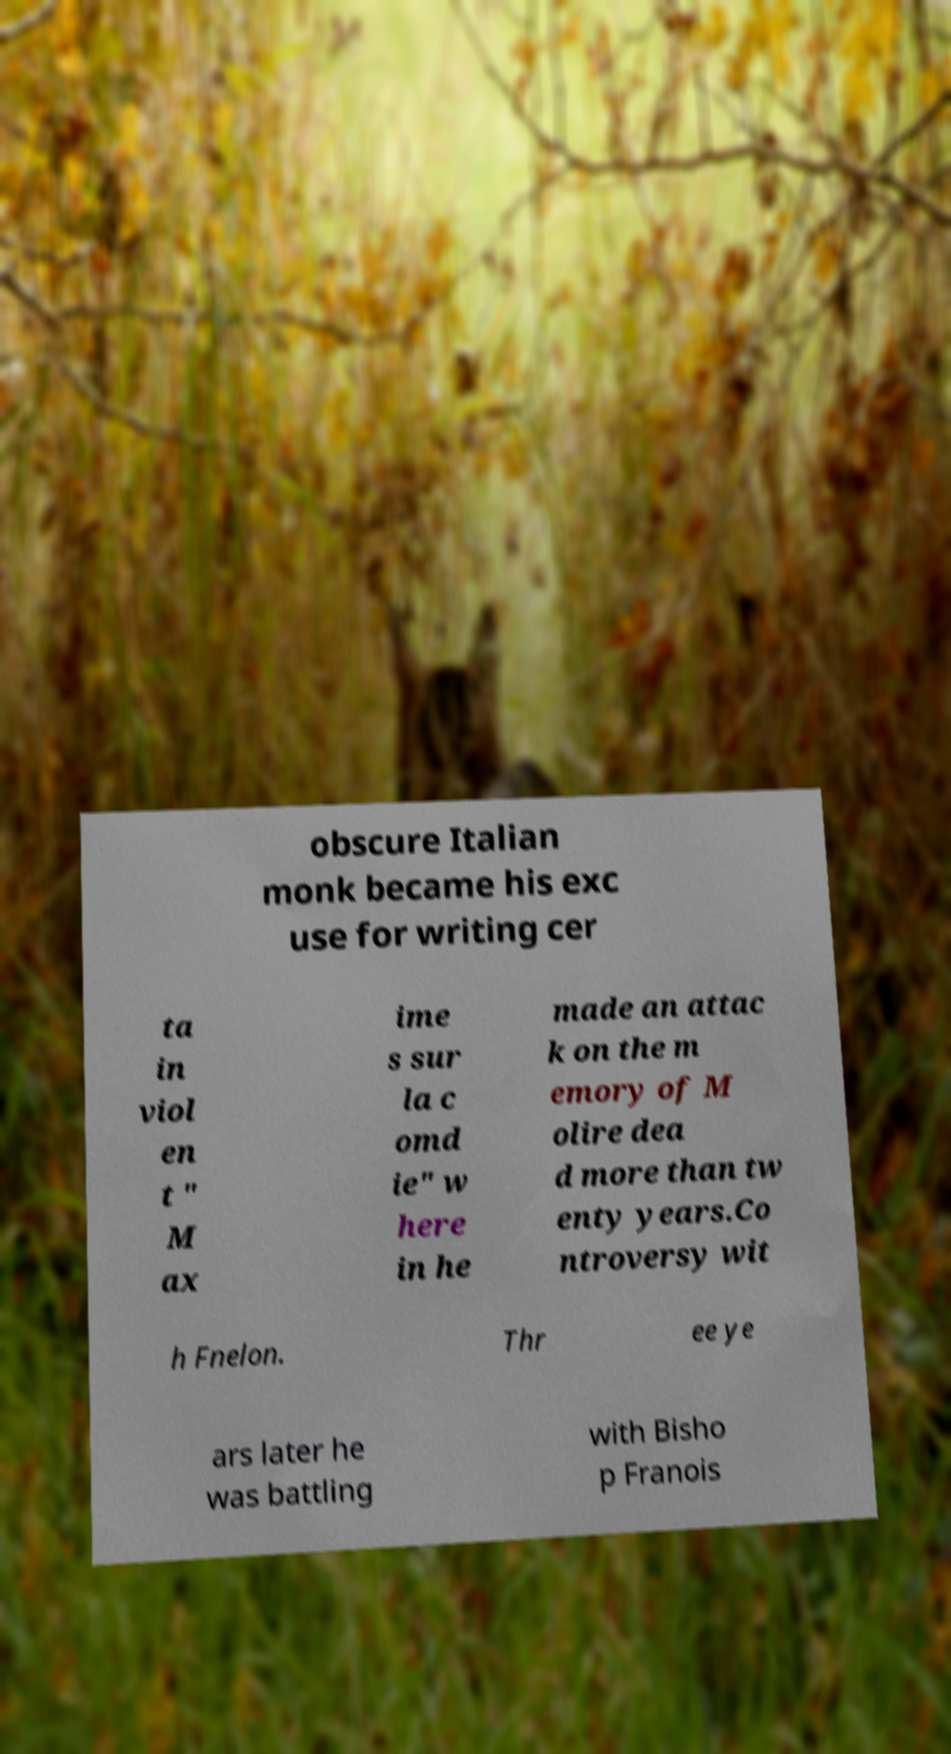What messages or text are displayed in this image? I need them in a readable, typed format. obscure Italian monk became his exc use for writing cer ta in viol en t " M ax ime s sur la c omd ie" w here in he made an attac k on the m emory of M olire dea d more than tw enty years.Co ntroversy wit h Fnelon. Thr ee ye ars later he was battling with Bisho p Franois 